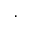Convert formula to latex. <formula><loc_0><loc_0><loc_500><loc_500>\cdot</formula> 